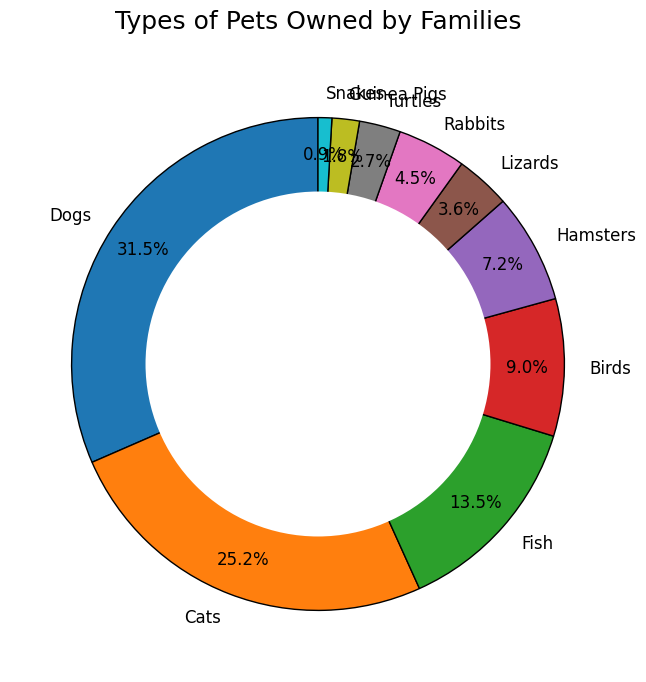Which type of pet is owned by the most families? Look at the segment with the highest percentage or largest slice in the donut chart.
Answer: Dogs Which type of pet is owned by the least number of families? Identify the smallest slice in the donut chart, which corresponds to the smallest percentage.
Answer: Snakes How many more families own dogs than own cats? Dogs have a count of 35, and cats have a count of 28. Subtract the count of cats from the count of dogs: 35 - 28.
Answer: 7 What percentage of families own either birds or hamsters? Find the percentages for birds and hamsters, then add them together (Birds: 10 families, Hamsters: 8 families. Total = 10 + 8 = 18. Calculate the percentage: (18/111) * 100 ≈ 16.2%).
Answer: 16.2% What is the total number of families that own exotic pets (lizards, turtles, snakes)? Sum the counts of lizards, turtles, and snakes: 4 + 3 + 1 = 8.
Answer: 8 Is the number of families owning fish greater than the number combined of those owning turtles and rabbits? Compare the count for fish (15) with the sum of counts for turtles (3) and rabbits (5): 15 versus (3 + 5 = 8).
Answer: Yes How much more popular are cats compared to birds? Subtract the count for birds (10) from the count for cats (28): 28 - 10.
Answer: 18 What proportion of families own cats relative to the total number of families surveyed? Calculate the percentage for cats: (28/111) * 100 ≈ 25.23%.
Answer: 25.23% Which pets are owned by fewer families than rabbits but more than guinea pigs? Look at the counts for pets and identify those between rabbits (5) and guinea pigs (2): Turtles (3).
Answer: Turtles What is the combined percentage of families owning hamsters, lizards, and rabbits? Sum the percentages of hamsters, lizards, and rabbits: Hamsters (8), Lizards (4), Rabbits (5). Total percentage = (8 + 4 + 5)/111 * 100 ≈ 15.32%.
Answer: 15.32% 